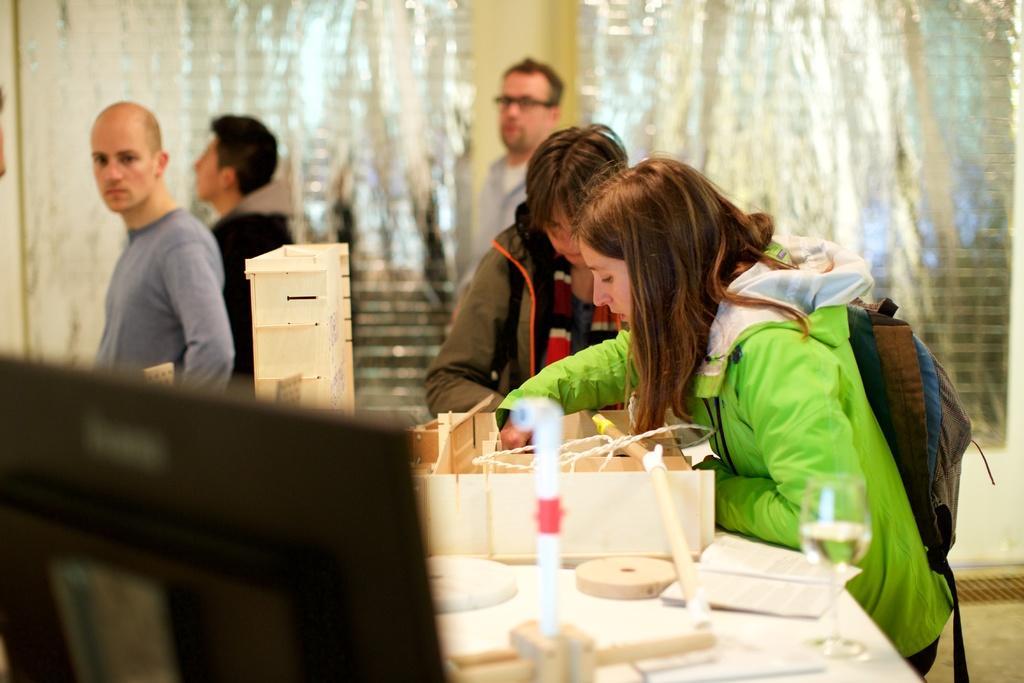Describe this image in one or two sentences. In this image we can see a few people, among them, one person is wearing the spectacles, there is a table, on the table, we can see a book, glass, monitor and some other objects, in the background it looks like the windows. 